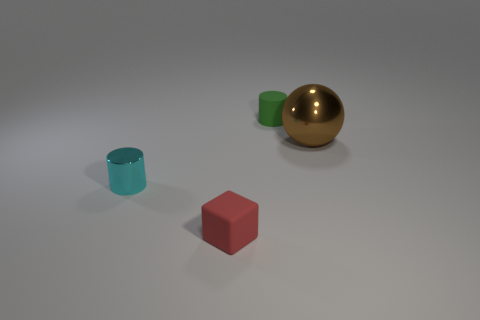There is a thing in front of the tiny cyan cylinder; does it have the same shape as the metallic object that is left of the green thing? The object in question appears to be a red cube, which does not have the same shape as the metallic sphere positioned to the left of the small green cylinder. The cube has six square faces, while the metallic sphere is round with no edges. 